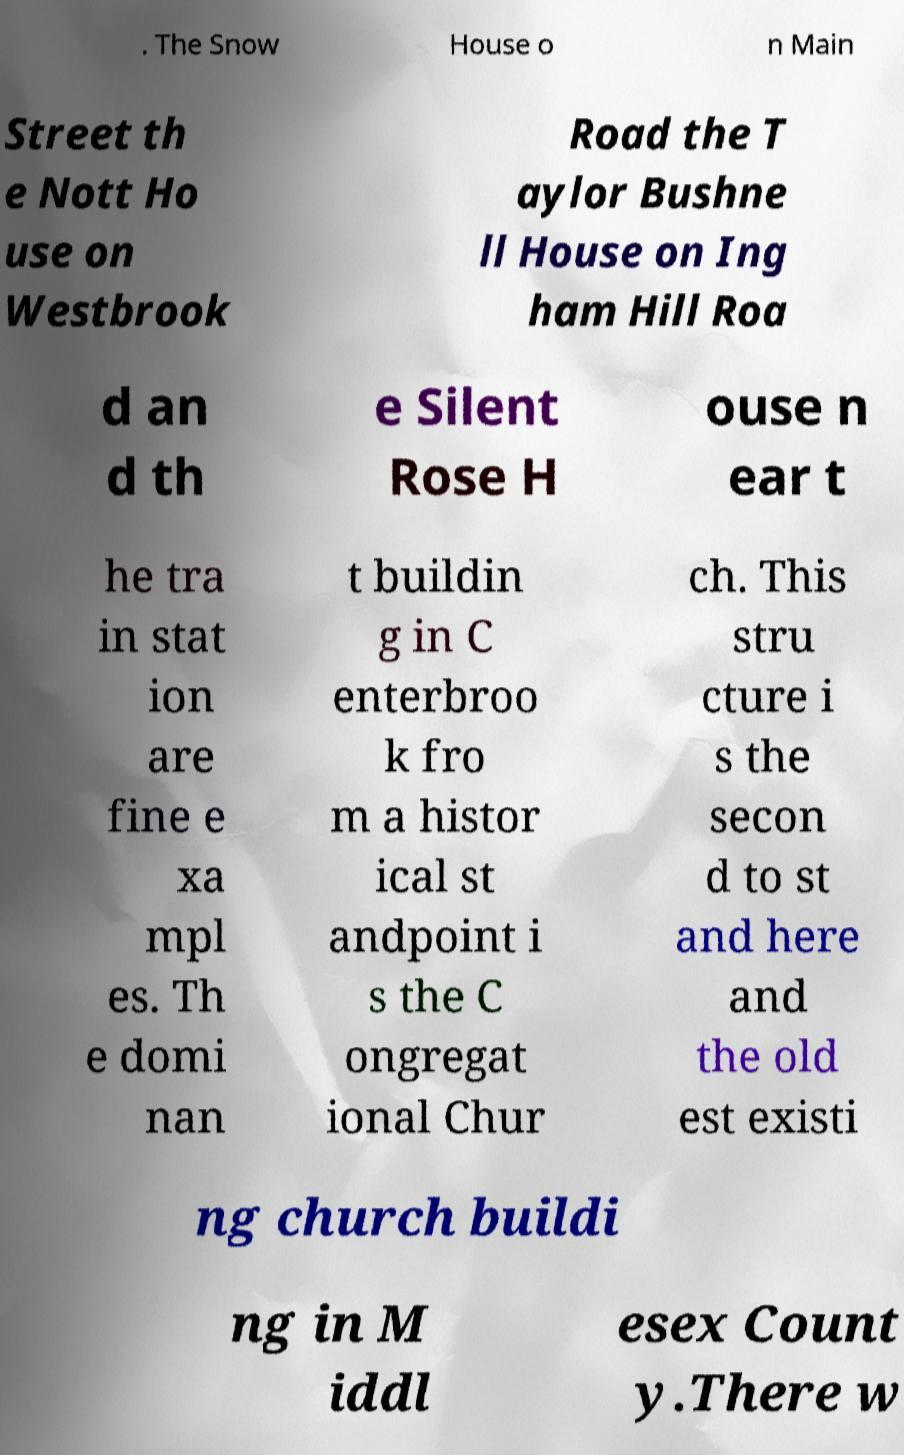I need the written content from this picture converted into text. Can you do that? . The Snow House o n Main Street th e Nott Ho use on Westbrook Road the T aylor Bushne ll House on Ing ham Hill Roa d an d th e Silent Rose H ouse n ear t he tra in stat ion are fine e xa mpl es. Th e domi nan t buildin g in C enterbroo k fro m a histor ical st andpoint i s the C ongregat ional Chur ch. This stru cture i s the secon d to st and here and the old est existi ng church buildi ng in M iddl esex Count y.There w 